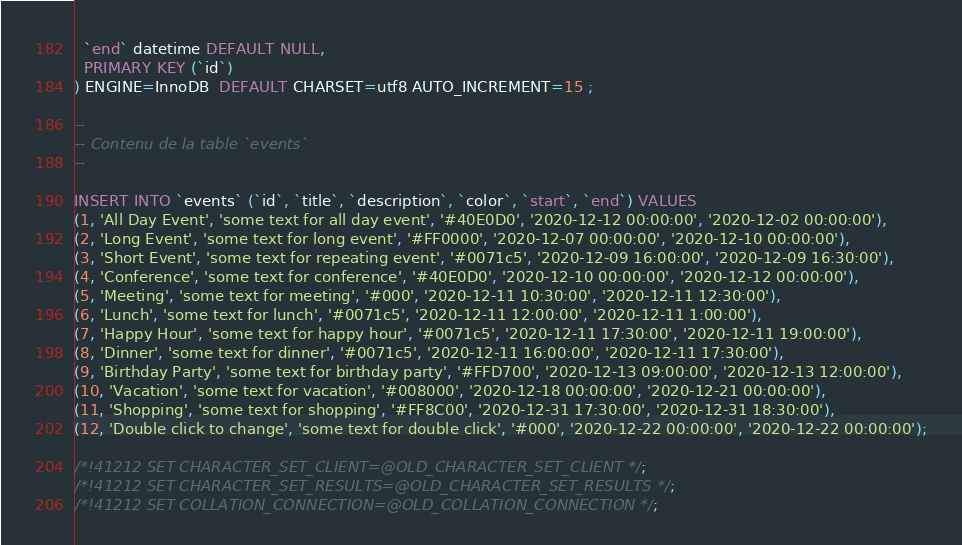Convert code to text. <code><loc_0><loc_0><loc_500><loc_500><_SQL_>  `end` datetime DEFAULT NULL,
  PRIMARY KEY (`id`)
) ENGINE=InnoDB  DEFAULT CHARSET=utf8 AUTO_INCREMENT=15 ;

--
-- Contenu de la table `events`
--

INSERT INTO `events` (`id`, `title`, `description`, `color`, `start`, `end`) VALUES
(1, 'All Day Event', 'some text for all day event', '#40E0D0', '2020-12-12 00:00:00', '2020-12-02 00:00:00'),
(2, 'Long Event', 'some text for long event', '#FF0000', '2020-12-07 00:00:00', '2020-12-10 00:00:00'),
(3, 'Short Event', 'some text for repeating event', '#0071c5', '2020-12-09 16:00:00', '2020-12-09 16:30:00'),
(4, 'Conference', 'some text for conference', '#40E0D0', '2020-12-10 00:00:00', '2020-12-12 00:00:00'),
(5, 'Meeting', 'some text for meeting', '#000', '2020-12-11 10:30:00', '2020-12-11 12:30:00'),
(6, 'Lunch', 'some text for lunch', '#0071c5', '2020-12-11 12:00:00', '2020-12-11 1:00:00'),
(7, 'Happy Hour', 'some text for happy hour', '#0071c5', '2020-12-11 17:30:00', '2020-12-11 19:00:00'),
(8, 'Dinner', 'some text for dinner', '#0071c5', '2020-12-11 16:00:00', '2020-12-11 17:30:00'),
(9, 'Birthday Party', 'some text for birthday party', '#FFD700', '2020-12-13 09:00:00', '2020-12-13 12:00:00'),
(10, 'Vacation', 'some text for vacation', '#008000', '2020-12-18 00:00:00', '2020-12-21 00:00:00'),
(11, 'Shopping', 'some text for shopping', '#FF8C00', '2020-12-31 17:30:00', '2020-12-31 18:30:00'),
(12, 'Double click to change', 'some text for double click', '#000', '2020-12-22 00:00:00', '2020-12-22 00:00:00');

/*!41212 SET CHARACTER_SET_CLIENT=@OLD_CHARACTER_SET_CLIENT */;
/*!41212 SET CHARACTER_SET_RESULTS=@OLD_CHARACTER_SET_RESULTS */;
/*!41212 SET COLLATION_CONNECTION=@OLD_COLLATION_CONNECTION */;
</code> 